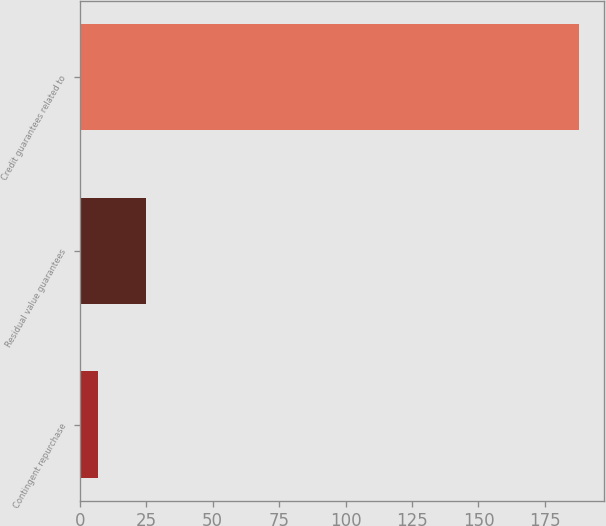Convert chart. <chart><loc_0><loc_0><loc_500><loc_500><bar_chart><fcel>Contingent repurchase<fcel>Residual value guarantees<fcel>Credit guarantees related to<nl><fcel>7<fcel>25.1<fcel>188<nl></chart> 